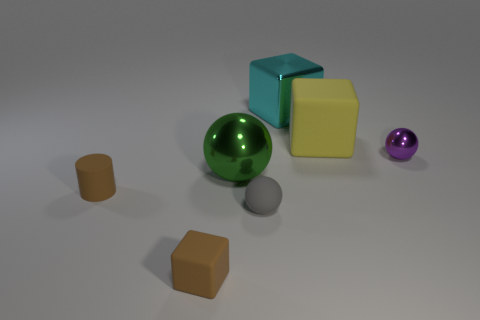Do the yellow rubber thing that is on the right side of the large shiny block and the large metallic object behind the purple metallic ball have the same shape?
Ensure brevity in your answer.  Yes. The small matte object that is both on the left side of the gray sphere and in front of the cylinder has what shape?
Make the answer very short. Cube. Are there any brown matte cylinders of the same size as the gray matte object?
Give a very brief answer. Yes. Do the small rubber cylinder and the rubber block left of the big green object have the same color?
Your answer should be compact. Yes. What is the material of the small gray object?
Ensure brevity in your answer.  Rubber. What color is the matte thing that is behind the small shiny thing?
Provide a succinct answer. Yellow. What number of large spheres are the same color as the cylinder?
Your answer should be compact. 0. What number of tiny objects are on the left side of the purple metallic object and to the right of the cylinder?
Your answer should be very brief. 2. The green object that is the same size as the yellow matte cube is what shape?
Provide a succinct answer. Sphere. What size is the gray sphere?
Offer a terse response. Small. 